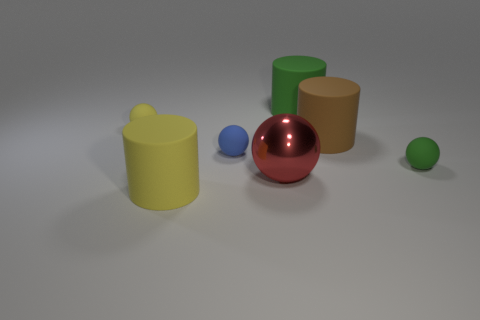Is there anything else that is the same material as the red thing?
Your response must be concise. No. Is the material of the cylinder in front of the small green object the same as the small green sphere?
Offer a very short reply. Yes. There is a rubber ball that is both to the right of the large yellow rubber thing and behind the green ball; what size is it?
Your response must be concise. Small. What is the size of the matte sphere to the right of the brown rubber thing?
Keep it short and to the point. Small. What is the shape of the big matte thing that is left of the green cylinder to the right of the large rubber cylinder in front of the small green rubber thing?
Provide a succinct answer. Cylinder. How many other objects are there of the same shape as the blue rubber thing?
Provide a succinct answer. 3. How many shiny things are either yellow objects or small blue things?
Your answer should be compact. 0. The large cylinder that is on the left side of the green rubber object that is behind the tiny yellow thing is made of what material?
Your answer should be very brief. Rubber. Are there more green rubber objects that are in front of the large green rubber object than small brown matte cubes?
Offer a very short reply. Yes. Are there any big yellow things made of the same material as the blue sphere?
Offer a very short reply. Yes. 